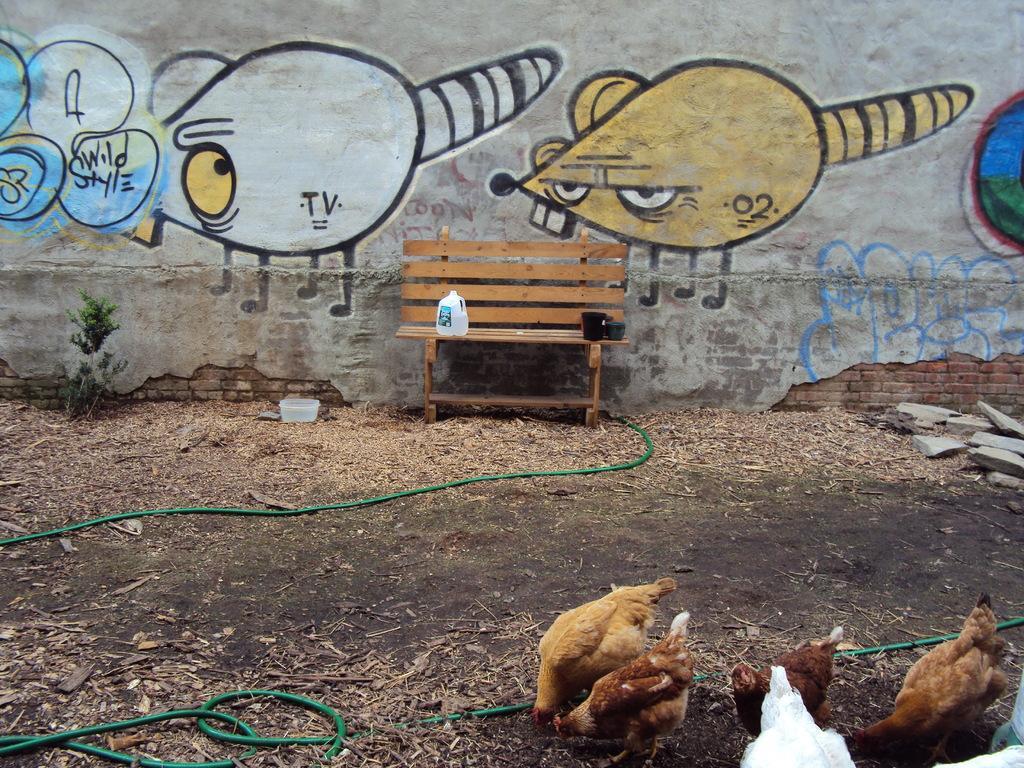Please provide a concise description of this image. This picture is of outside. In the foreground we can see a green color pipe and a group of hens standing on the ground. In the center there is a bench and a bottle placed on the top of the bench. In the background there is a painting on the wall, a plant and some stones placed on the ground. 